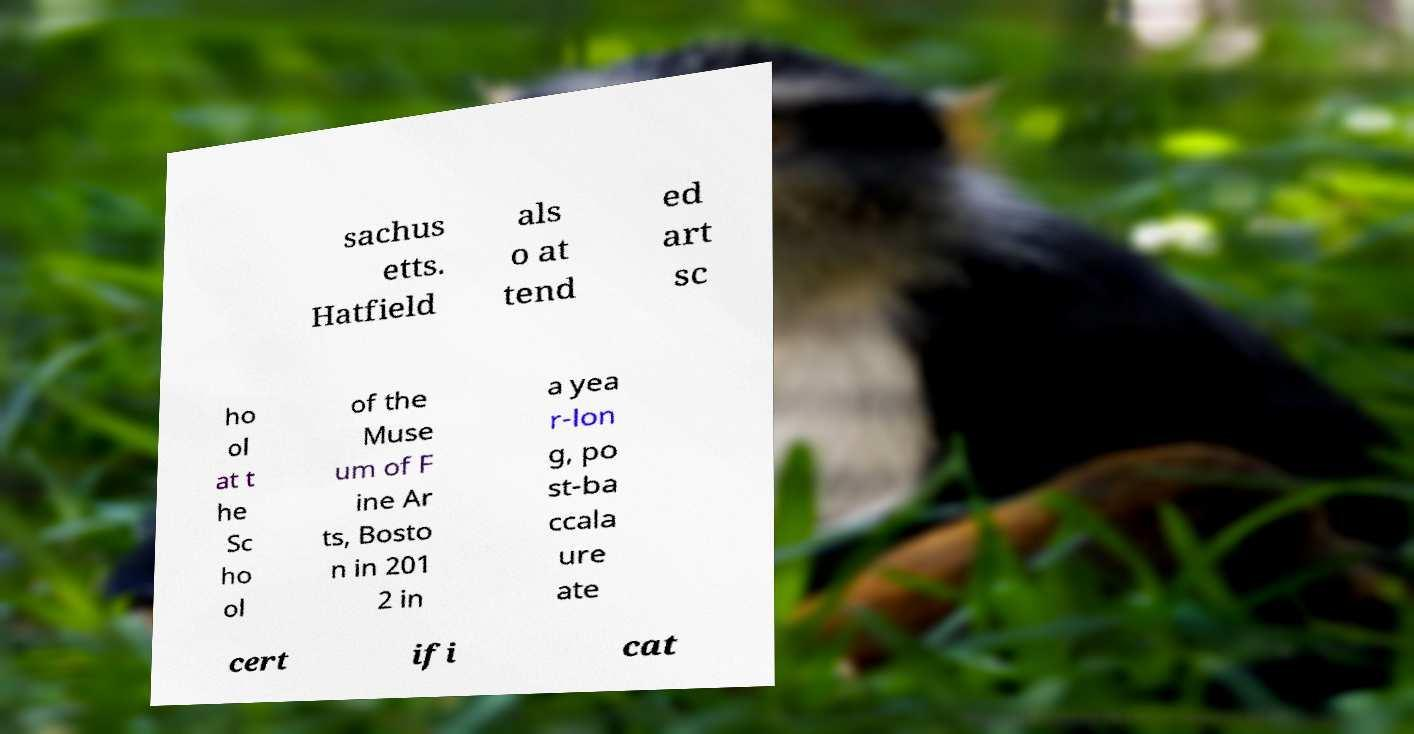Please identify and transcribe the text found in this image. sachus etts. Hatfield als o at tend ed art sc ho ol at t he Sc ho ol of the Muse um of F ine Ar ts, Bosto n in 201 2 in a yea r-lon g, po st-ba ccala ure ate cert ifi cat 